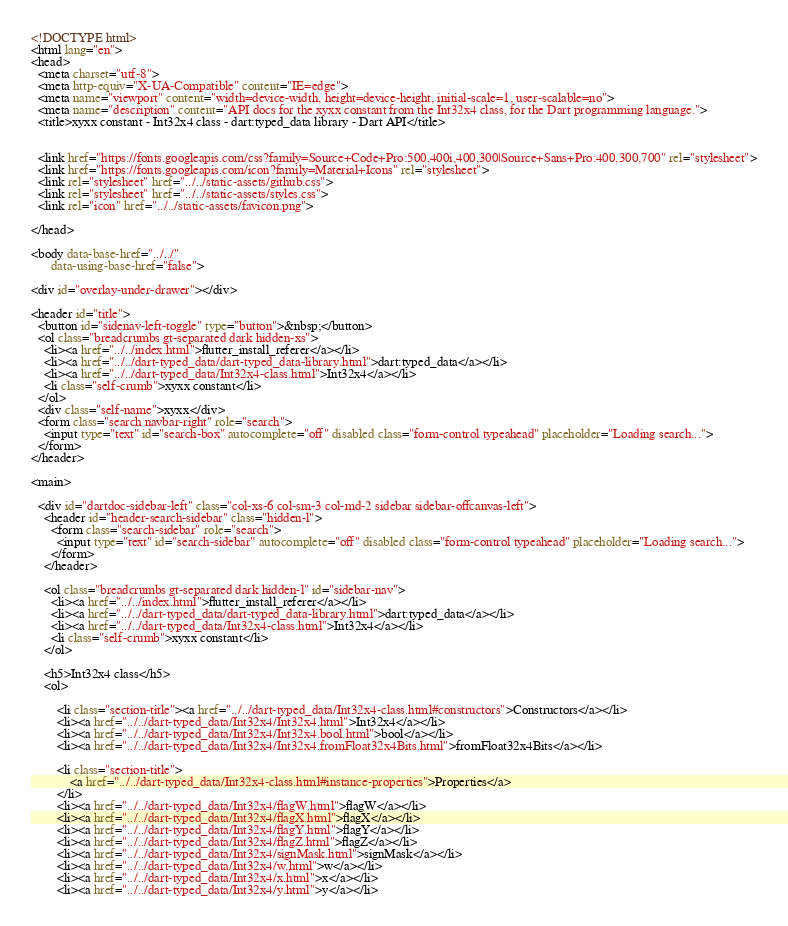Convert code to text. <code><loc_0><loc_0><loc_500><loc_500><_HTML_><!DOCTYPE html>
<html lang="en">
<head>
  <meta charset="utf-8">
  <meta http-equiv="X-UA-Compatible" content="IE=edge">
  <meta name="viewport" content="width=device-width, height=device-height, initial-scale=1, user-scalable=no">
  <meta name="description" content="API docs for the xyxx constant from the Int32x4 class, for the Dart programming language.">
  <title>xyxx constant - Int32x4 class - dart:typed_data library - Dart API</title>

  
  <link href="https://fonts.googleapis.com/css?family=Source+Code+Pro:500,400i,400,300|Source+Sans+Pro:400,300,700" rel="stylesheet">
  <link href="https://fonts.googleapis.com/icon?family=Material+Icons" rel="stylesheet">
  <link rel="stylesheet" href="../../static-assets/github.css">
  <link rel="stylesheet" href="../../static-assets/styles.css">
  <link rel="icon" href="../../static-assets/favicon.png">

</head>

<body data-base-href="../../"
      data-using-base-href="false">

<div id="overlay-under-drawer"></div>

<header id="title">
  <button id="sidenav-left-toggle" type="button">&nbsp;</button>
  <ol class="breadcrumbs gt-separated dark hidden-xs">
    <li><a href="../../index.html">flutter_install_referer</a></li>
    <li><a href="../../dart-typed_data/dart-typed_data-library.html">dart:typed_data</a></li>
    <li><a href="../../dart-typed_data/Int32x4-class.html">Int32x4</a></li>
    <li class="self-crumb">xyxx constant</li>
  </ol>
  <div class="self-name">xyxx</div>
  <form class="search navbar-right" role="search">
    <input type="text" id="search-box" autocomplete="off" disabled class="form-control typeahead" placeholder="Loading search...">
  </form>
</header>

<main>

  <div id="dartdoc-sidebar-left" class="col-xs-6 col-sm-3 col-md-2 sidebar sidebar-offcanvas-left">
    <header id="header-search-sidebar" class="hidden-l">
      <form class="search-sidebar" role="search">
        <input type="text" id="search-sidebar" autocomplete="off" disabled class="form-control typeahead" placeholder="Loading search...">
      </form>
    </header>
    
    <ol class="breadcrumbs gt-separated dark hidden-l" id="sidebar-nav">
      <li><a href="../../index.html">flutter_install_referer</a></li>
      <li><a href="../../dart-typed_data/dart-typed_data-library.html">dart:typed_data</a></li>
      <li><a href="../../dart-typed_data/Int32x4-class.html">Int32x4</a></li>
      <li class="self-crumb">xyxx constant</li>
    </ol>
    
    <h5>Int32x4 class</h5>
    <ol>
    
        <li class="section-title"><a href="../../dart-typed_data/Int32x4-class.html#constructors">Constructors</a></li>
        <li><a href="../../dart-typed_data/Int32x4/Int32x4.html">Int32x4</a></li>
        <li><a href="../../dart-typed_data/Int32x4/Int32x4.bool.html">bool</a></li>
        <li><a href="../../dart-typed_data/Int32x4/Int32x4.fromFloat32x4Bits.html">fromFloat32x4Bits</a></li>
    
        <li class="section-title">
            <a href="../../dart-typed_data/Int32x4-class.html#instance-properties">Properties</a>
        </li>
        <li><a href="../../dart-typed_data/Int32x4/flagW.html">flagW</a></li>
        <li><a href="../../dart-typed_data/Int32x4/flagX.html">flagX</a></li>
        <li><a href="../../dart-typed_data/Int32x4/flagY.html">flagY</a></li>
        <li><a href="../../dart-typed_data/Int32x4/flagZ.html">flagZ</a></li>
        <li><a href="../../dart-typed_data/Int32x4/signMask.html">signMask</a></li>
        <li><a href="../../dart-typed_data/Int32x4/w.html">w</a></li>
        <li><a href="../../dart-typed_data/Int32x4/x.html">x</a></li>
        <li><a href="../../dart-typed_data/Int32x4/y.html">y</a></li></code> 